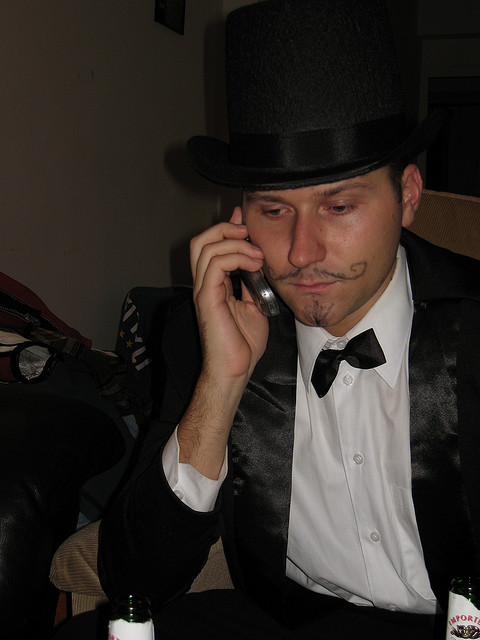What is the possible mood of the scene captured in the photo? The scene presents a somewhat somber or contemplative mood, as the man appears to be in deep thought or concentration while on the phone. Despite his festive attire, the environment and his facial expression do not convey a sense of joy or celebration at the moment captured. 